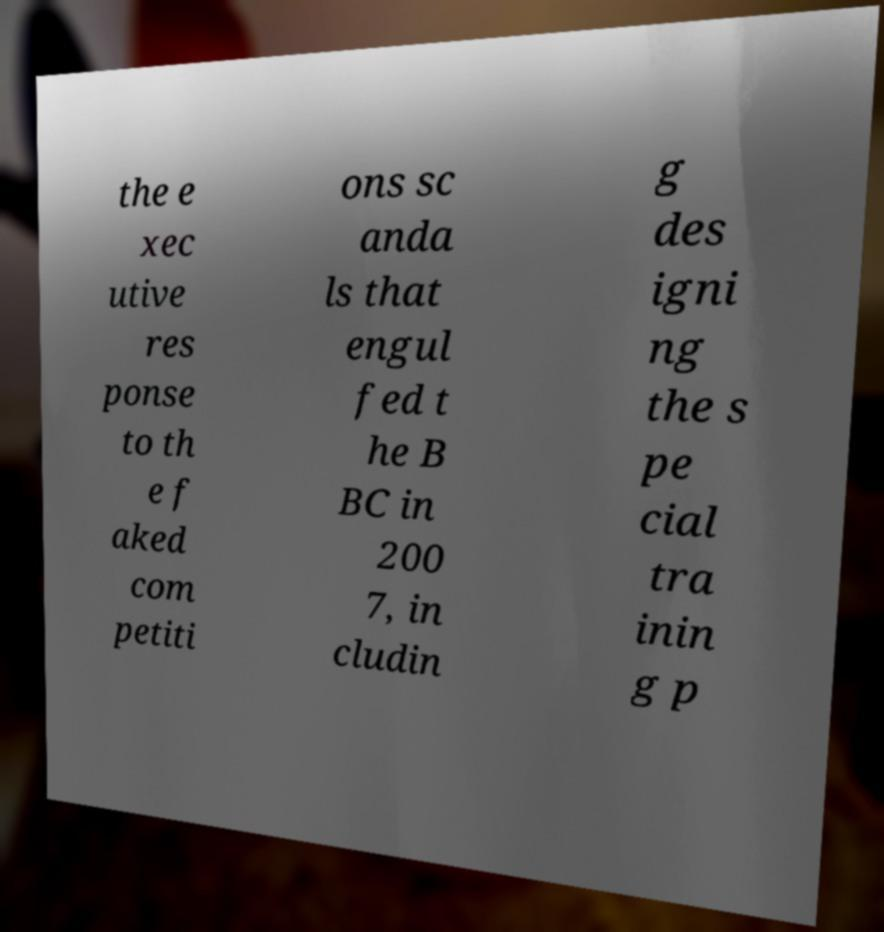Please read and relay the text visible in this image. What does it say? the e xec utive res ponse to th e f aked com petiti ons sc anda ls that engul fed t he B BC in 200 7, in cludin g des igni ng the s pe cial tra inin g p 